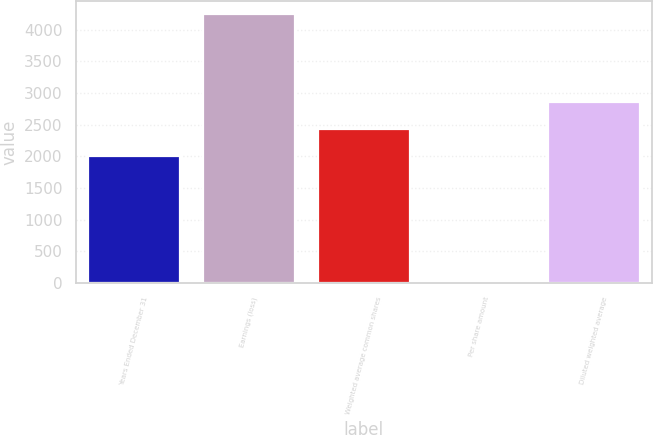Convert chart to OTSL. <chart><loc_0><loc_0><loc_500><loc_500><bar_chart><fcel>Years Ended December 31<fcel>Earnings (loss)<fcel>Weighted average common shares<fcel>Per share amount<fcel>Diluted weighted average<nl><fcel>2008<fcel>4244<fcel>2432.21<fcel>1.87<fcel>2856.42<nl></chart> 